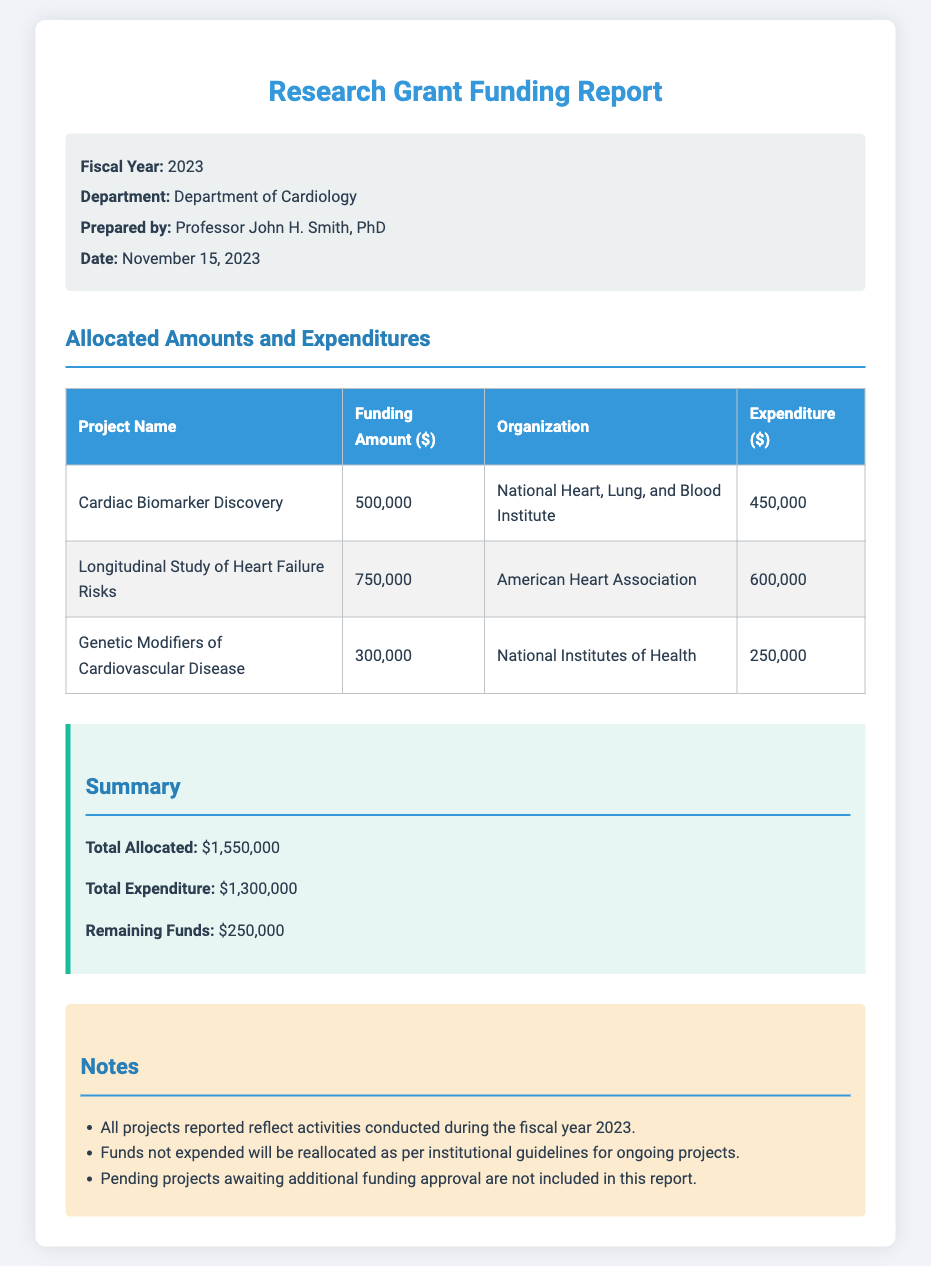What was the total allocated amount for the projects? The total allocated amount is found in the summary section, which lists $1,550,000.
Answer: $1,550,000 Who prepared the report? The report states that it was prepared by Professor John H. Smith, PhD.
Answer: Professor John H. Smith, PhD What is the expenditure for the "Longitudinal Study of Heart Failure Risks" project? The expenditure for this project is detailed in the table, which shows $600,000.
Answer: $600,000 What is the remaining funds after expenditures? The summary section provides the remaining funds, which total $250,000.
Answer: $250,000 Which organization funded the "Cardiac Biomarker Discovery" project? The table indicates that the funding organization is the National Heart, Lung, and Blood Institute.
Answer: National Heart, Lung, and Blood Institute What percentage of the allocated amount was spent across all projects? Total expenditure divided by total allocated gives the percentage: ($1,300,000 / $1,550,000) * 100, which approximately equals 83.87%.
Answer: 83.87% What is a condition mentioned regarding the unspent funds? The notes section states that funds not expended will be reallocated as per institutional guidelines.
Answer: Reallocated as per institutional guidelines What information is excluded from this report? The notes clarify that pending projects awaiting additional funding approval are not included in this report.
Answer: Pending projects awaiting additional funding approval 